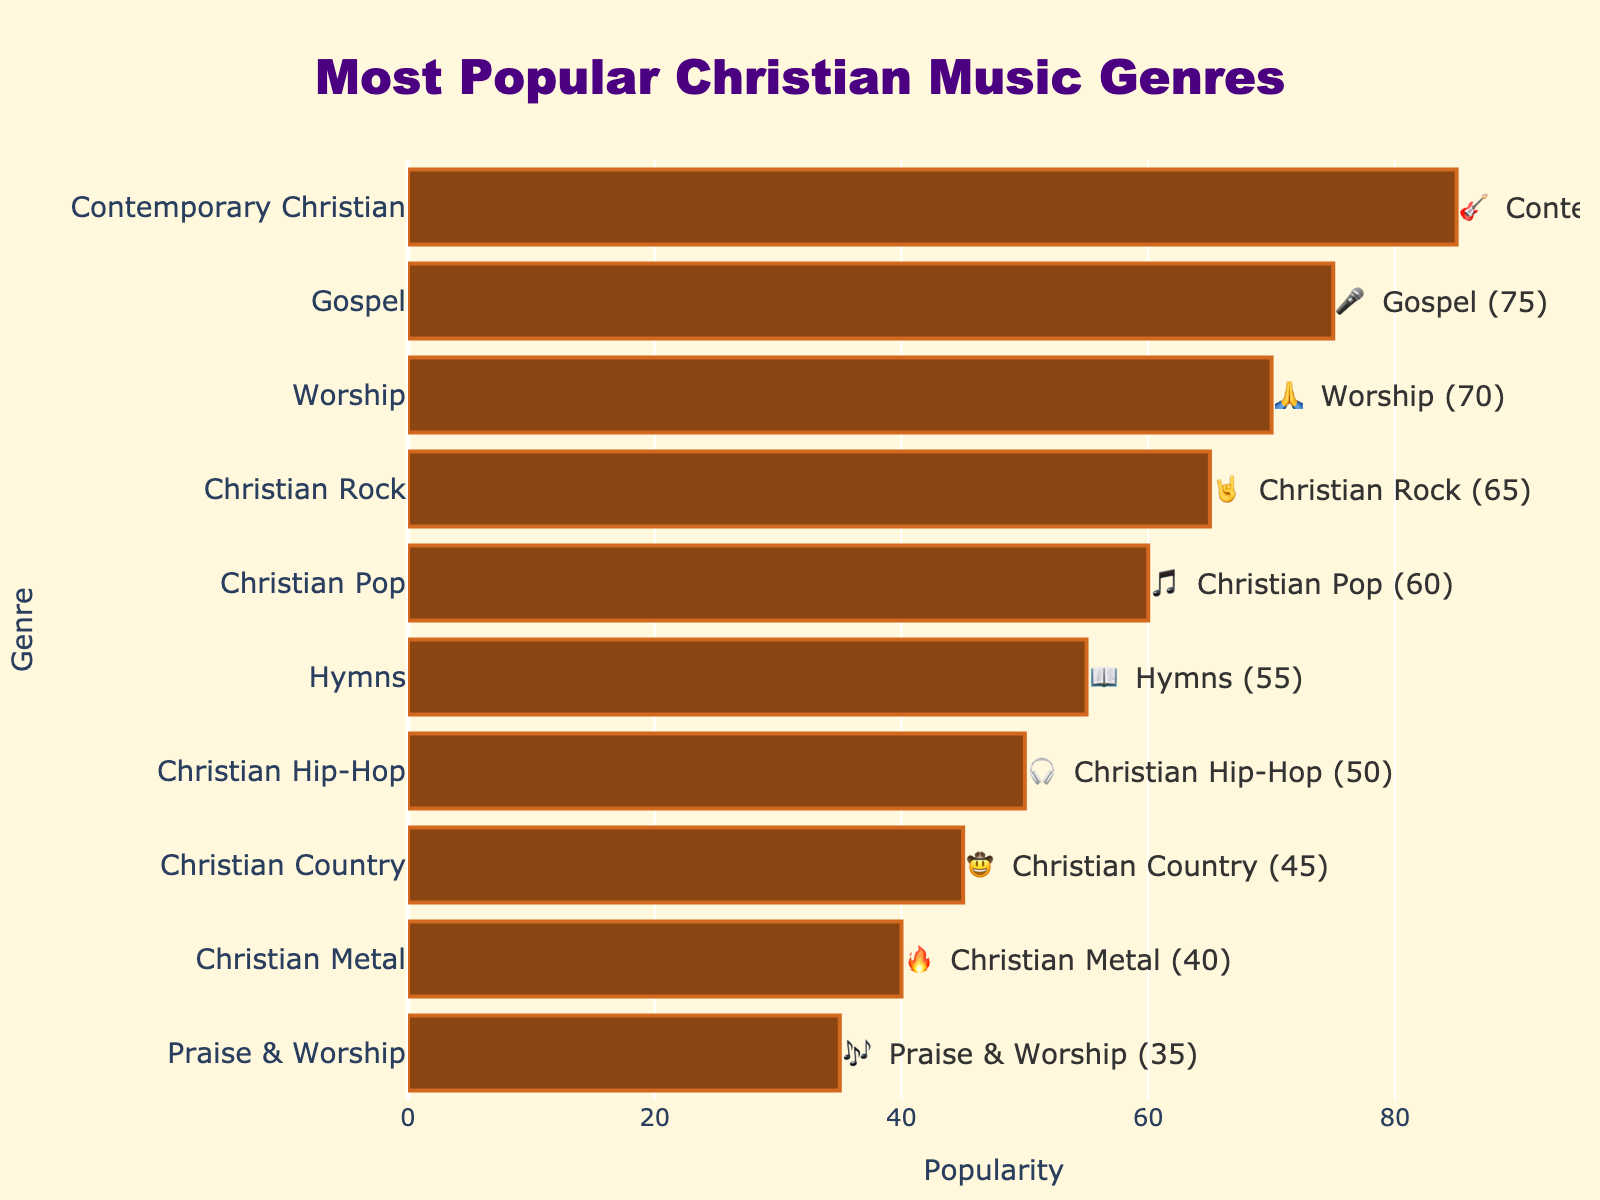What's the title of the chart? The title is usually placed at the top of the chart. In this case, it reads "Most Popular Christian Music Genres".
Answer: Most Popular Christian Music Genres What genre has the highest popularity? The bar chart lists genres by their popularity. The genre with the bar extending furthest to the right, indicating the highest value, is "Contemporary Christian".
Answer: Contemporary Christian Which genre is represented with a 🔥 emoji? Each genre has an emoji next to it in the chart. The genre associated with 🔥 is "Christian Metal".
Answer: Christian Metal How many genres have a popularity score of 60 or more? Count the bars extending to scores of 60 or more on the x-axis. These genres are Contemporary Christian, Gospel, Worship, Christian Rock, and Christian Pop, totaling 5.
Answer: 5 What's the difference in popularity between the most and least popular genres? Subtract the popularity of the least popular genre (Praise & Worship, 35) from the most popular genre (Contemporary Christian, 85). The difference is 85 - 35.
Answer: 50 Which genre has exactly 75 popularity? Locate the bar that extends to the 75 mark on the x-axis. The genre at this position is "Gospel".
Answer: Gospel What's the color of the bars in the chart? The bars are colored in a shade of brown, which visually matches the theme of the chart.
Answer: Brown By how much does the popularity of "Christian Rock" exceed "Hymns"? Subtract the popularity of Hymns (55) from Christian Rock (65). The difference is 65 - 55.
Answer: 10 What genre is found between Gospel and Christian Rock in terms of popularity? In the sorted bar chart, after Gospel (75), the next genre in descending order is Worship (70), followed then by Christian Rock (65).
Answer: Worship How many genres have a popularity of less than 50? Count the bars that extend to values less than 50 on the x-axis. The genres in this range are Christian Hip-Hop, Christian Country, Christian Metal, and Praise & Worship, making it 4 genres.
Answer: 4 